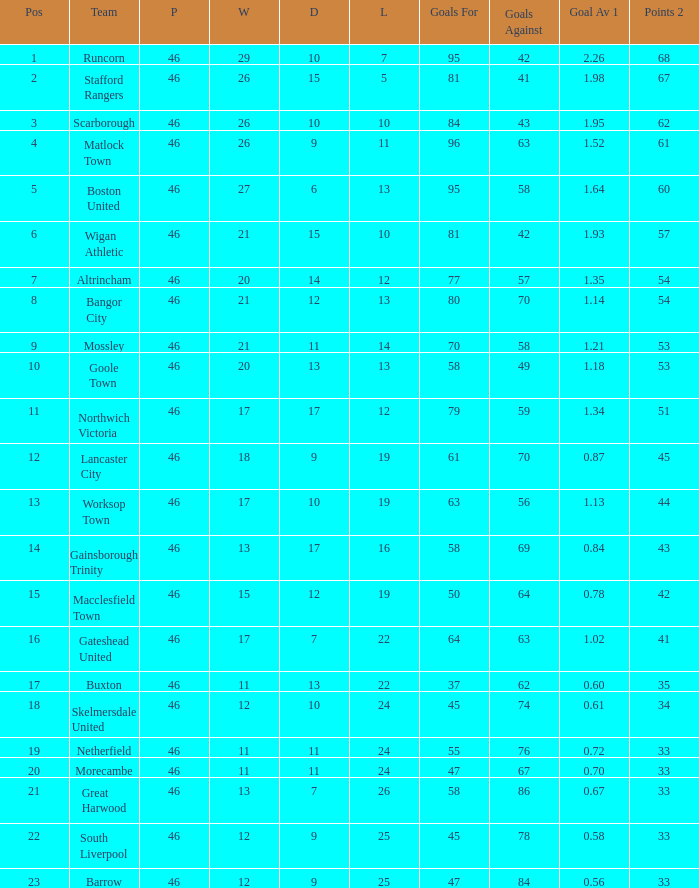What is the highest position of the Bangor City team? 8.0. 